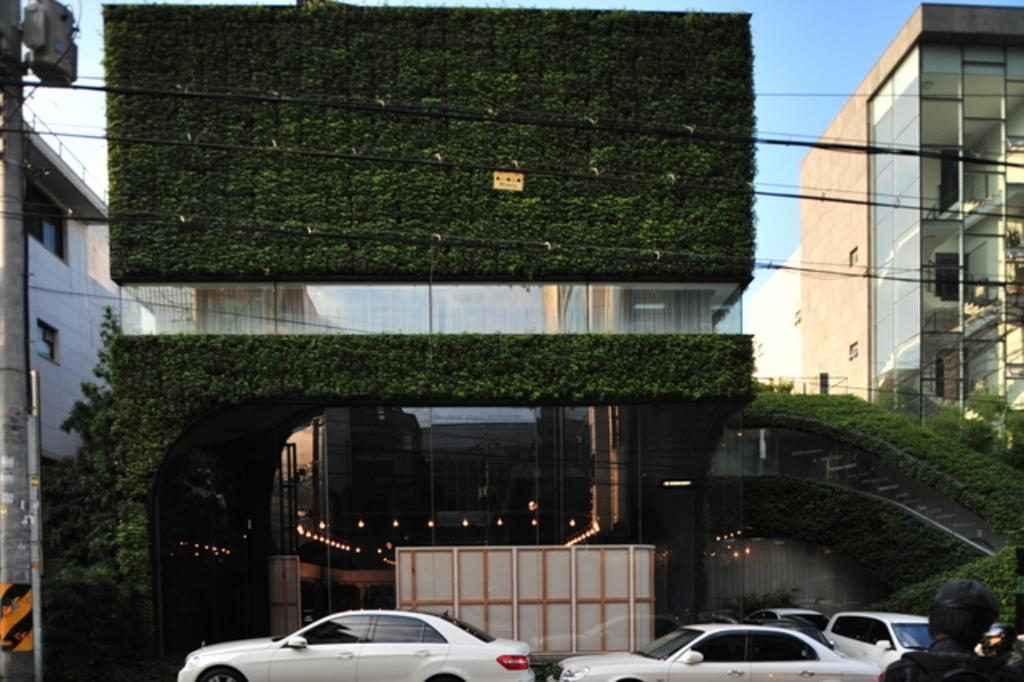What type of structures can be seen in the image? There are buildings in the image. What else is present in the image besides buildings? There are vehicles, a pole with wires, lights, people, and a gate visible in the image. Can you describe the pole with wires in the image? Yes, there is a pole with wires in the image. What is visible at the top of the image? The sky is visible at the top of the image. What type of doll is being used for business purposes in the image? There is no doll present in the image, and therefore no such activity can be observed. How many birds are visible on the gate in the image? There are no birds visible on the gate in the image. 